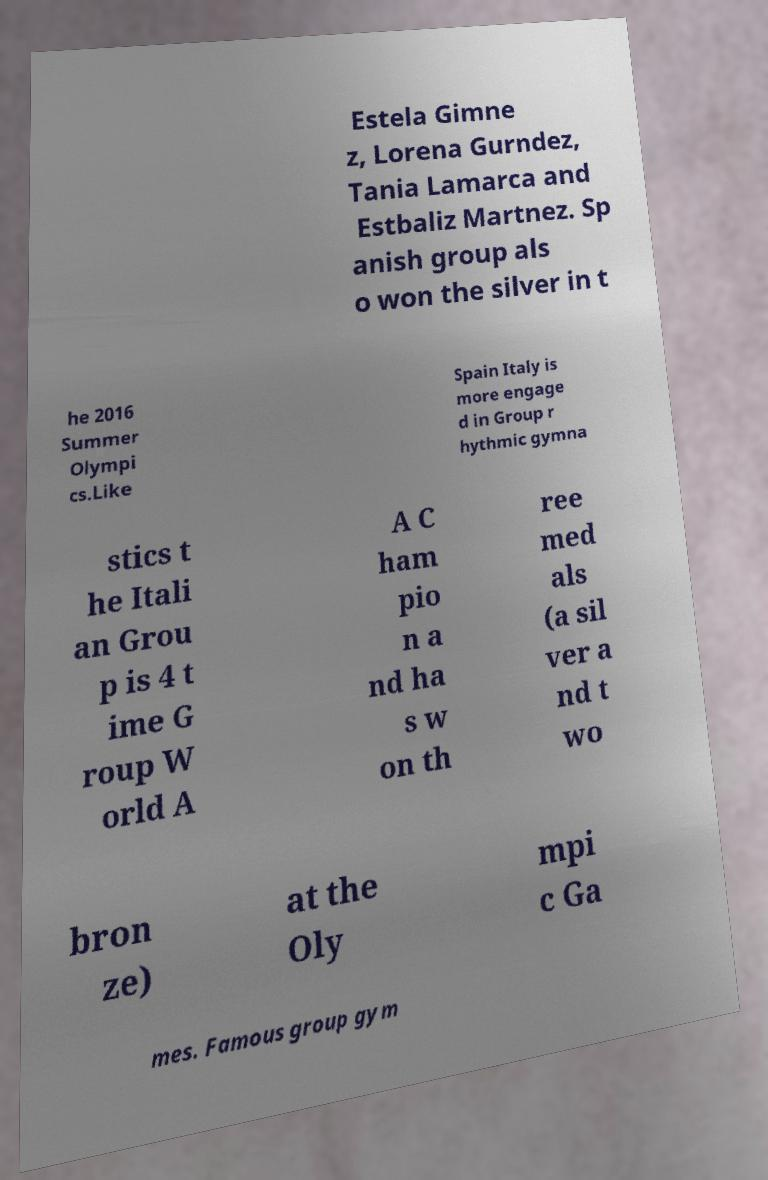Could you assist in decoding the text presented in this image and type it out clearly? Estela Gimne z, Lorena Gurndez, Tania Lamarca and Estbaliz Martnez. Sp anish group als o won the silver in t he 2016 Summer Olympi cs.Like Spain Italy is more engage d in Group r hythmic gymna stics t he Itali an Grou p is 4 t ime G roup W orld A A C ham pio n a nd ha s w on th ree med als (a sil ver a nd t wo bron ze) at the Oly mpi c Ga mes. Famous group gym 